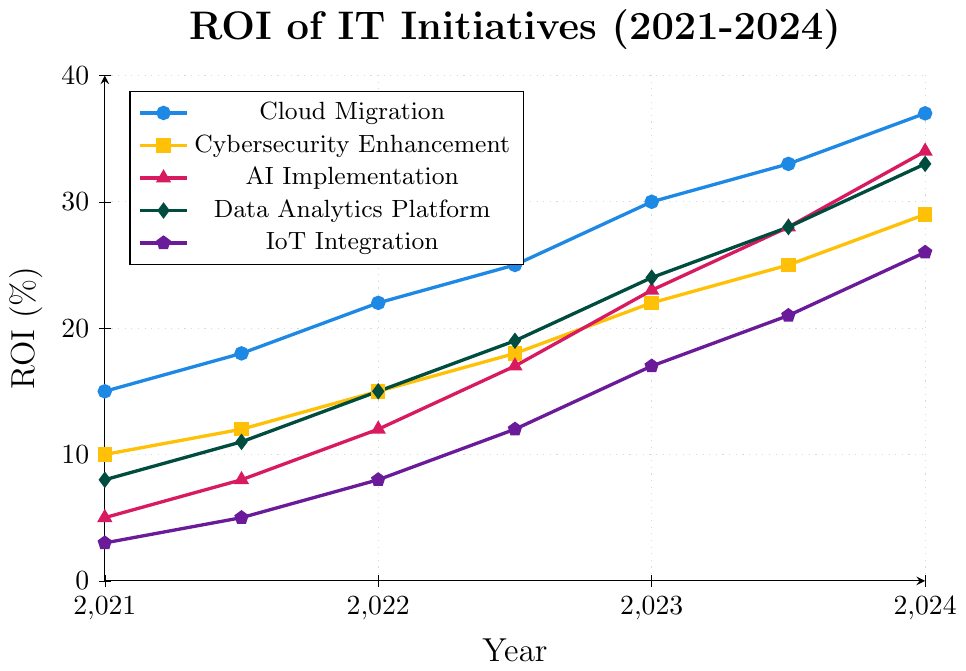Which IT initiative had the highest ROI in 2024? In 2024, the ROI for "Cloud Migration" is 37%, "Cybersecurity Enhancement" is 29%, "AI Implementation" is 34%, "Data Analytics Platform" is 33%, and "IoT Integration" is 26%. The highest is "Cloud Migration" at 37%.
Answer: Cloud Migration How did the ROI for AI Implementation change from 2021 to 2024? In 2021, the ROI for "AI Implementation" is 5%, and in 2024, it is 34%. The change is 34% - 5% = 29%.
Answer: 29% Which two IT initiatives had the same ROI in 2023.5? In 2023.5, "AI Implementation" and "Data Analytics Platform" both have an ROI of 28%.
Answer: AI Implementation and Data Analytics Platform Between 2021.5 and 2022.5, which initiative had the greatest increase in ROI, and what was the increase? For each initiative, calculate the change:
- Cloud Migration: 25% - 18% = 7%
- Cybersecurity Enhancement: 18% - 12% = 6%
- AI Implementation: 17% - 8% = 9%
- Data Analytics Platform: 19% - 11% = 8%
- IoT Integration: 12% - 5% = 7%
"AI Implementation" had the greatest increase of 9%.
Answer: AI Implementation, 9% What is the average ROI of Cybersecurity Enhancement across the entire period? Calculate the sum of ROIs and divide by the number of data points:
(10 + 12 + 15 + 18 + 22 + 25 + 29) / 7 = 131 / 7 ≈ 18.71%
Answer: 18.71% What was the ROI difference between Cloud Migration and IoT Integration in 2023? In 2023, Cloud Migration’s ROI is 30% and IoT Integration’s ROI is 17%. The difference is 30% - 17% = 13%.
Answer: 13% Which initiative experienced the second highest ROI increase from 2022.5 to 2023.5? Calculate the increase for each initiative:
- Cloud Migration: 33% - 25% = 8%
- Cybersecurity Enhancement: 25% - 18% = 7%
- AI Implementation: 28% - 17% = 11%
- Data Analytics Platform: 28% - 19% = 9%
- IoT Integration: 21% - 12% = 9%
The "Data Analytics Platform" and "IoT Integration" both had a second highest increase of 9%.
Answer: Data Analytics Platform and IoT Integration, 9% 